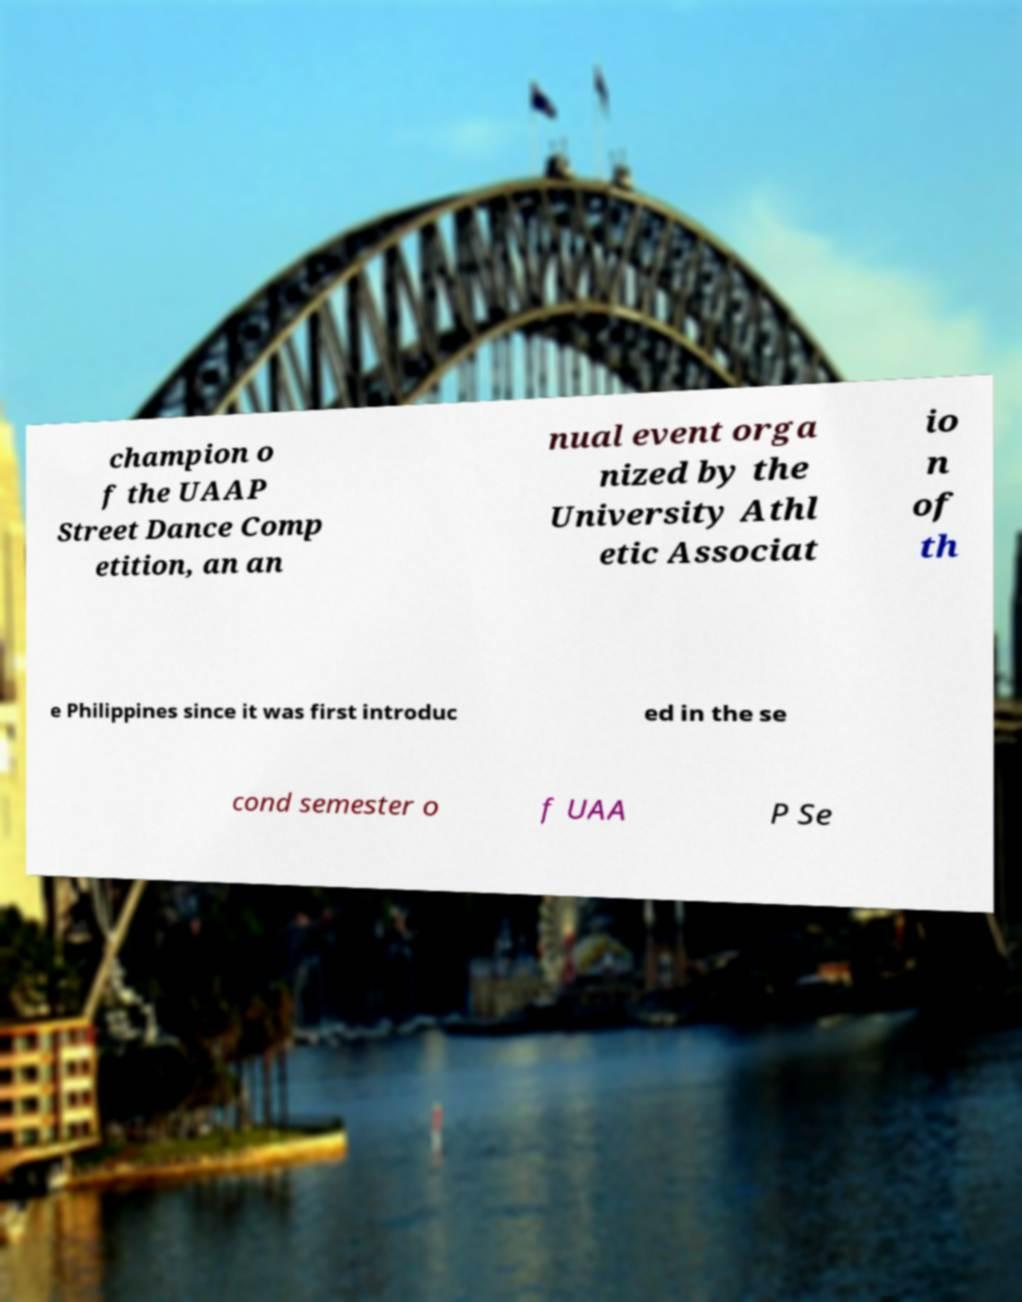There's text embedded in this image that I need extracted. Can you transcribe it verbatim? champion o f the UAAP Street Dance Comp etition, an an nual event orga nized by the University Athl etic Associat io n of th e Philippines since it was first introduc ed in the se cond semester o f UAA P Se 